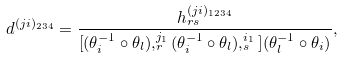<formula> <loc_0><loc_0><loc_500><loc_500>d ^ { ( j i ) _ { 2 3 4 } } = \frac { h _ { r s } ^ { ( j i ) _ { 1 2 3 4 } } } { [ ( \theta _ { i } ^ { - 1 } \circ \theta _ { l } ) , _ { r } ^ { j _ { 1 } } ( \theta _ { i } ^ { - 1 } \circ \theta _ { l } ) , _ { s } ^ { i _ { 1 } } ] ( \theta _ { l } ^ { - 1 } \circ \theta _ { i } ) } ,</formula> 